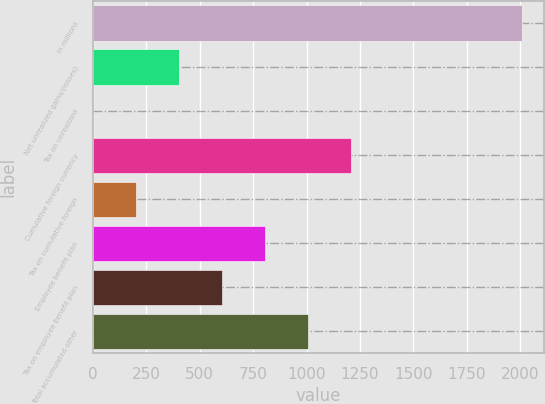<chart> <loc_0><loc_0><loc_500><loc_500><bar_chart><fcel>in millions<fcel>Net unrealized gains/(losses)<fcel>Tax on unrealized<fcel>Cumulative foreign currency<fcel>Tax on cumulative foreign<fcel>Employee benefit plan<fcel>Tax on employee benefit plan<fcel>Total accumulated other<nl><fcel>2009<fcel>403.08<fcel>1.6<fcel>1206.04<fcel>202.34<fcel>804.56<fcel>603.82<fcel>1005.3<nl></chart> 